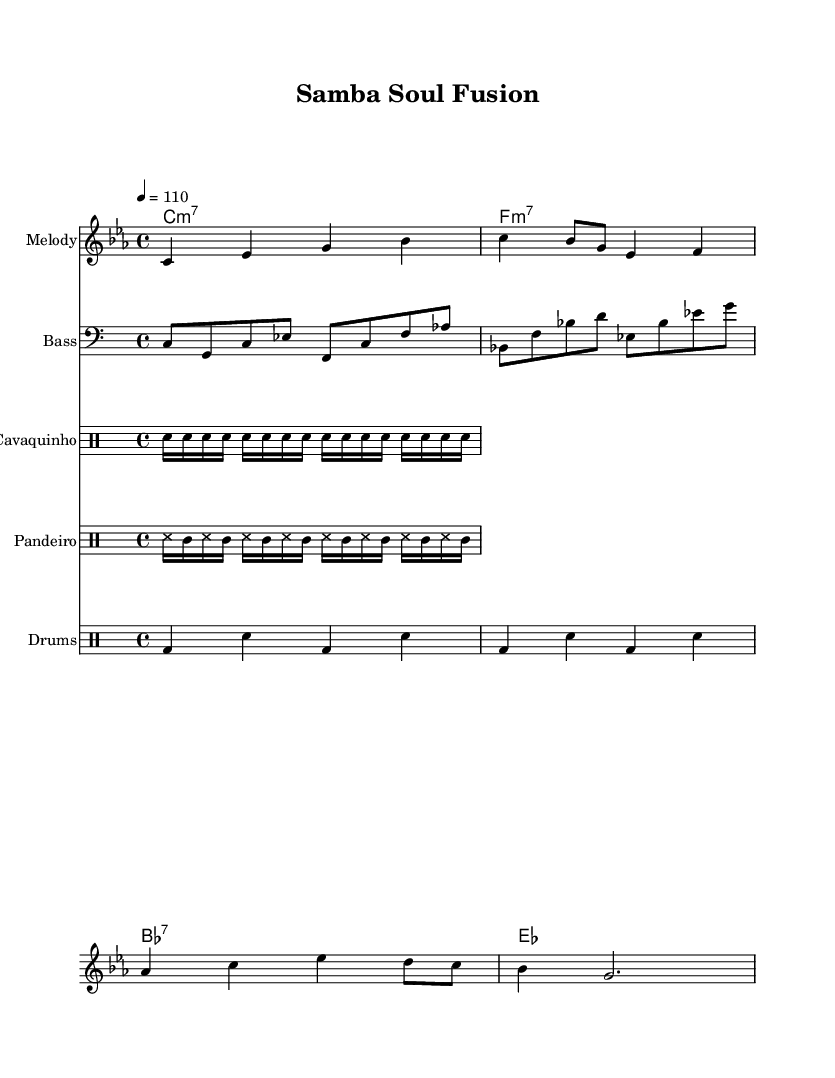What is the key signature of this music? The key signature is C minor, which has three flats: B flat, E flat, and A flat. This can be identified from the global section of the code where it specifies `\key c \minor`.
Answer: C minor What is the time signature of the piece? The time signature is indicated as 4/4, which means there are four beats in each measure, and the quarter note receives one beat. This is also specified in the global section: `\time 4/4`.
Answer: 4/4 What tempo marking is indicated? The tempo marking is indicated as 110 beats per minute (BPM), stated in the global section of the code as `\tempo 4 = 110`, meaning the quarter note gets 110 beats per minute.
Answer: 110 What type of chord is used in the first measure of harmonies? The first chord in the harmonies is identified as C minor 7, denoted as `c1:m7` in the chord mode section. The "1" indicates it's in root position.
Answer: C minor 7 What instrument plays the pandeiro pattern? The pandeiro pattern is played by the instrument identified as "Pandeiro". This is specified in the score generation code under the `\new DrumStaff`, where it lists the instrument name.
Answer: Pandeiro What rhythmic element is repeated in the cavaquinho strums? The rhythmic element is the "sn" (snare), which is repeated throughout the cavaquinho strum patterns. The strums are indicated in the drummode section, where "sn" appears consistently.
Answer: sn 